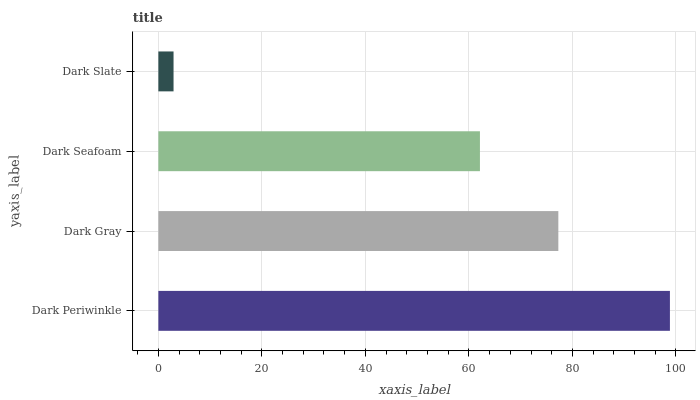Is Dark Slate the minimum?
Answer yes or no. Yes. Is Dark Periwinkle the maximum?
Answer yes or no. Yes. Is Dark Gray the minimum?
Answer yes or no. No. Is Dark Gray the maximum?
Answer yes or no. No. Is Dark Periwinkle greater than Dark Gray?
Answer yes or no. Yes. Is Dark Gray less than Dark Periwinkle?
Answer yes or no. Yes. Is Dark Gray greater than Dark Periwinkle?
Answer yes or no. No. Is Dark Periwinkle less than Dark Gray?
Answer yes or no. No. Is Dark Gray the high median?
Answer yes or no. Yes. Is Dark Seafoam the low median?
Answer yes or no. Yes. Is Dark Seafoam the high median?
Answer yes or no. No. Is Dark Gray the low median?
Answer yes or no. No. 